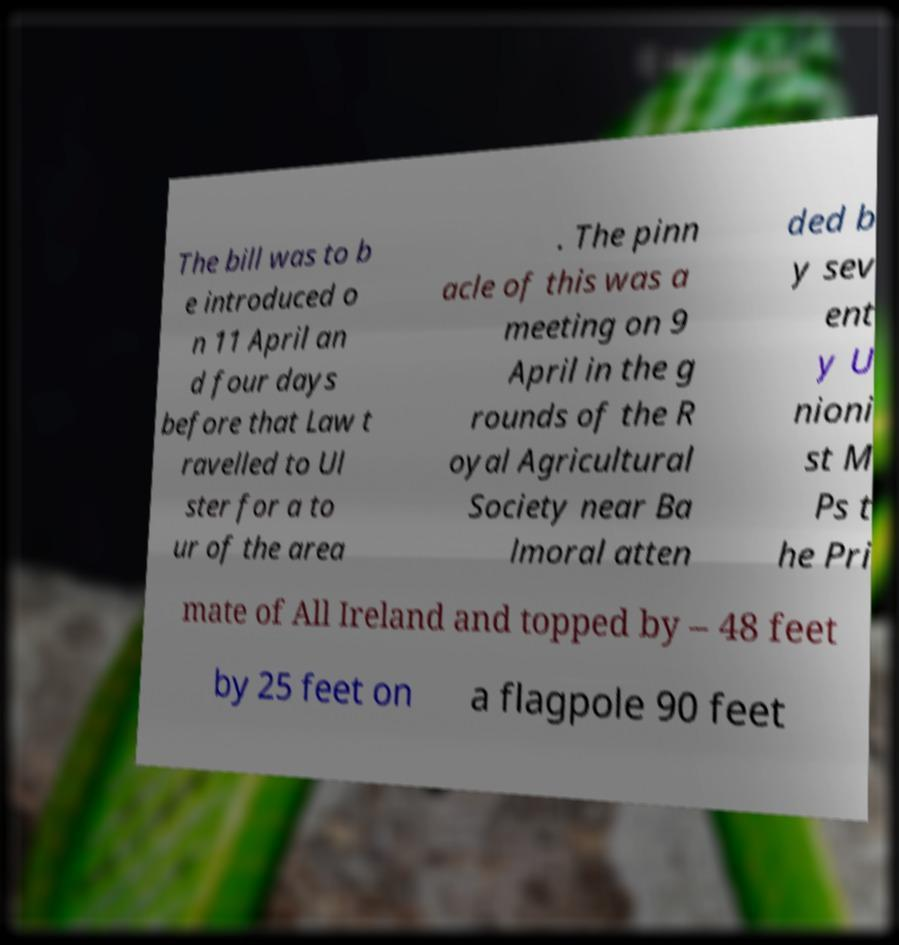Could you assist in decoding the text presented in this image and type it out clearly? The bill was to b e introduced o n 11 April an d four days before that Law t ravelled to Ul ster for a to ur of the area . The pinn acle of this was a meeting on 9 April in the g rounds of the R oyal Agricultural Society near Ba lmoral atten ded b y sev ent y U nioni st M Ps t he Pri mate of All Ireland and topped by – 48 feet by 25 feet on a flagpole 90 feet 